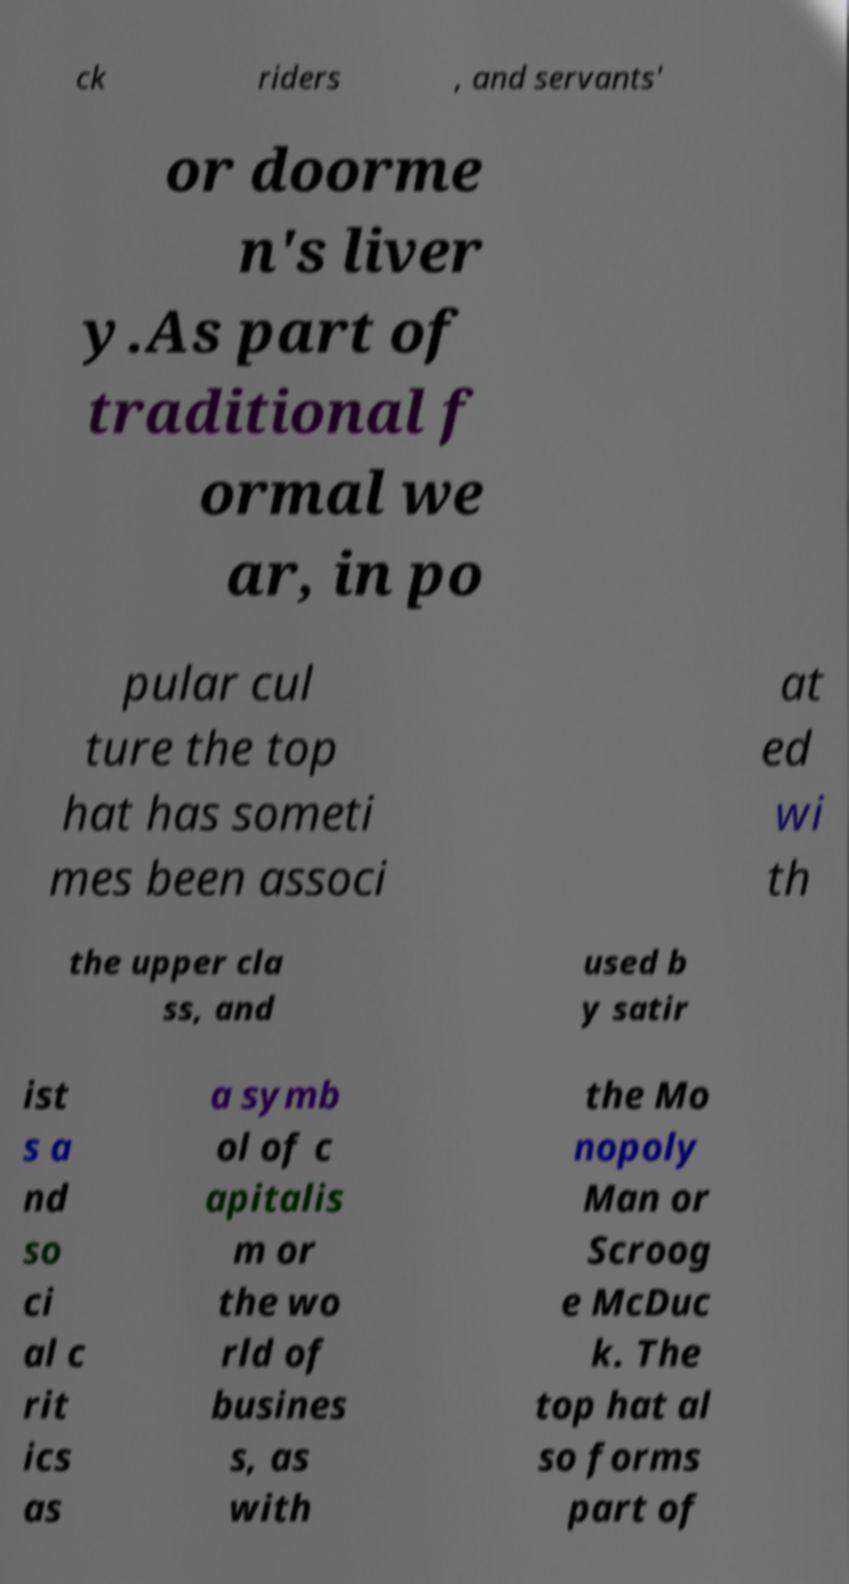Could you extract and type out the text from this image? ck riders , and servants' or doorme n's liver y.As part of traditional f ormal we ar, in po pular cul ture the top hat has someti mes been associ at ed wi th the upper cla ss, and used b y satir ist s a nd so ci al c rit ics as a symb ol of c apitalis m or the wo rld of busines s, as with the Mo nopoly Man or Scroog e McDuc k. The top hat al so forms part of 